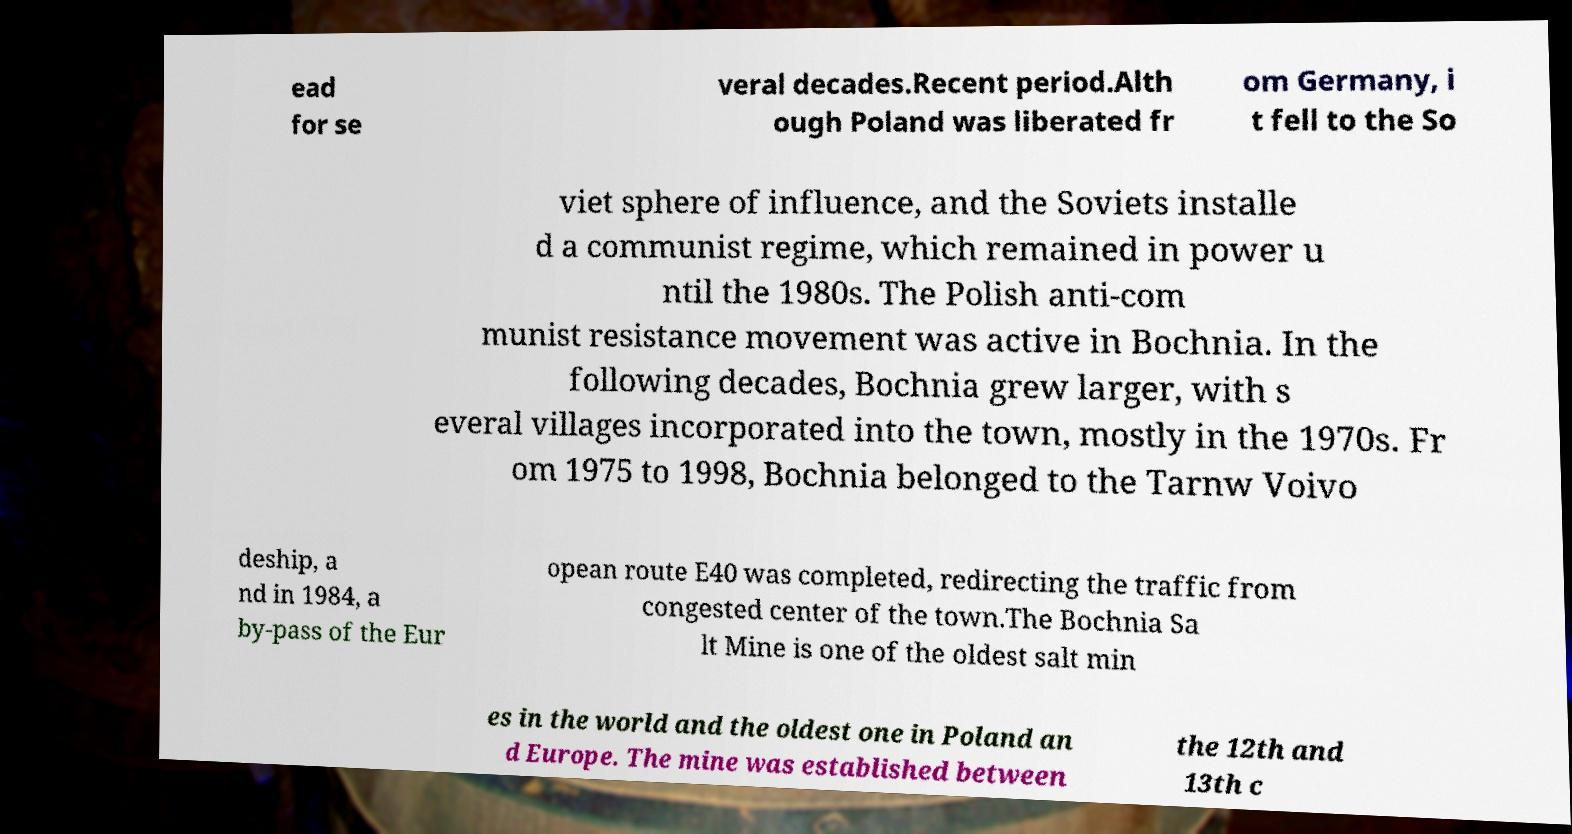For documentation purposes, I need the text within this image transcribed. Could you provide that? ead for se veral decades.Recent period.Alth ough Poland was liberated fr om Germany, i t fell to the So viet sphere of influence, and the Soviets installe d a communist regime, which remained in power u ntil the 1980s. The Polish anti-com munist resistance movement was active in Bochnia. In the following decades, Bochnia grew larger, with s everal villages incorporated into the town, mostly in the 1970s. Fr om 1975 to 1998, Bochnia belonged to the Tarnw Voivo deship, a nd in 1984, a by-pass of the Eur opean route E40 was completed, redirecting the traffic from congested center of the town.The Bochnia Sa lt Mine is one of the oldest salt min es in the world and the oldest one in Poland an d Europe. The mine was established between the 12th and 13th c 